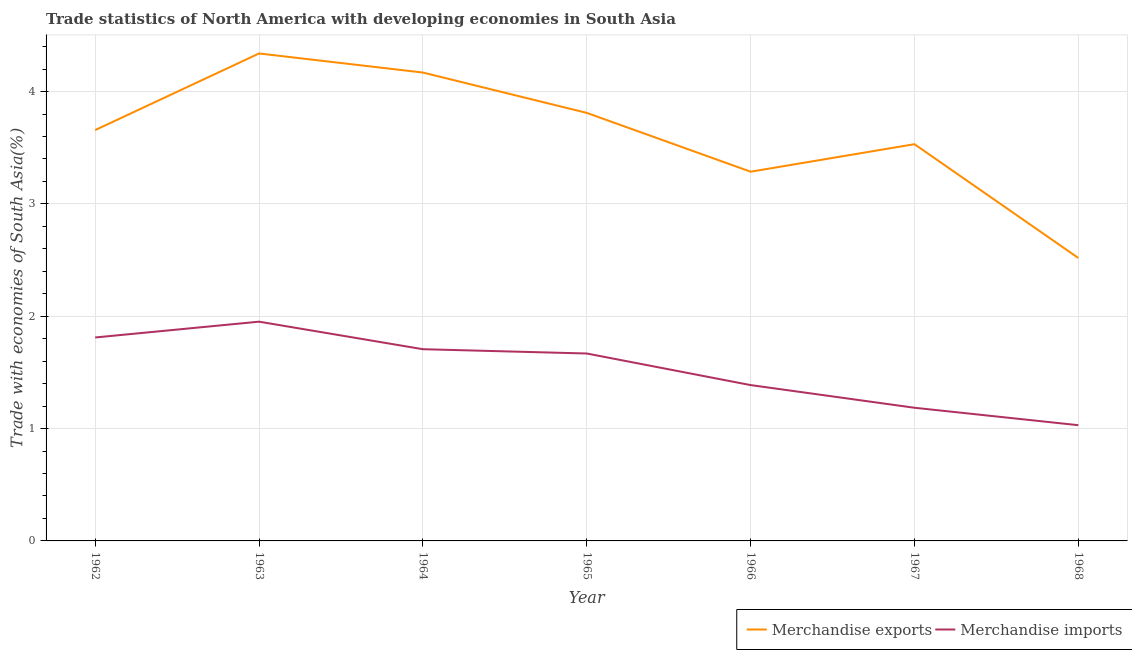Does the line corresponding to merchandise imports intersect with the line corresponding to merchandise exports?
Your answer should be very brief. No. What is the merchandise imports in 1965?
Your answer should be very brief. 1.67. Across all years, what is the maximum merchandise imports?
Keep it short and to the point. 1.95. Across all years, what is the minimum merchandise exports?
Offer a very short reply. 2.52. In which year was the merchandise exports minimum?
Your answer should be compact. 1968. What is the total merchandise imports in the graph?
Offer a very short reply. 10.74. What is the difference between the merchandise exports in 1964 and that in 1966?
Keep it short and to the point. 0.88. What is the difference between the merchandise imports in 1966 and the merchandise exports in 1962?
Offer a terse response. -2.27. What is the average merchandise imports per year?
Provide a short and direct response. 1.53. In the year 1968, what is the difference between the merchandise exports and merchandise imports?
Provide a succinct answer. 1.49. What is the ratio of the merchandise imports in 1966 to that in 1968?
Ensure brevity in your answer.  1.35. Is the difference between the merchandise exports in 1963 and 1966 greater than the difference between the merchandise imports in 1963 and 1966?
Offer a very short reply. Yes. What is the difference between the highest and the second highest merchandise exports?
Your answer should be compact. 0.17. What is the difference between the highest and the lowest merchandise imports?
Your response must be concise. 0.92. In how many years, is the merchandise exports greater than the average merchandise exports taken over all years?
Ensure brevity in your answer.  4. Is the sum of the merchandise imports in 1964 and 1965 greater than the maximum merchandise exports across all years?
Make the answer very short. No. How many years are there in the graph?
Provide a succinct answer. 7. Are the values on the major ticks of Y-axis written in scientific E-notation?
Provide a succinct answer. No. Does the graph contain any zero values?
Provide a short and direct response. No. Where does the legend appear in the graph?
Give a very brief answer. Bottom right. What is the title of the graph?
Your answer should be compact. Trade statistics of North America with developing economies in South Asia. Does "International Tourists" appear as one of the legend labels in the graph?
Your answer should be very brief. No. What is the label or title of the Y-axis?
Offer a terse response. Trade with economies of South Asia(%). What is the Trade with economies of South Asia(%) in Merchandise exports in 1962?
Give a very brief answer. 3.66. What is the Trade with economies of South Asia(%) of Merchandise imports in 1962?
Your answer should be compact. 1.81. What is the Trade with economies of South Asia(%) of Merchandise exports in 1963?
Offer a very short reply. 4.34. What is the Trade with economies of South Asia(%) in Merchandise imports in 1963?
Provide a short and direct response. 1.95. What is the Trade with economies of South Asia(%) in Merchandise exports in 1964?
Ensure brevity in your answer.  4.17. What is the Trade with economies of South Asia(%) in Merchandise imports in 1964?
Ensure brevity in your answer.  1.71. What is the Trade with economies of South Asia(%) in Merchandise exports in 1965?
Your answer should be very brief. 3.81. What is the Trade with economies of South Asia(%) of Merchandise imports in 1965?
Keep it short and to the point. 1.67. What is the Trade with economies of South Asia(%) of Merchandise exports in 1966?
Your answer should be very brief. 3.29. What is the Trade with economies of South Asia(%) in Merchandise imports in 1966?
Your answer should be very brief. 1.39. What is the Trade with economies of South Asia(%) of Merchandise exports in 1967?
Your answer should be very brief. 3.53. What is the Trade with economies of South Asia(%) in Merchandise imports in 1967?
Your response must be concise. 1.19. What is the Trade with economies of South Asia(%) in Merchandise exports in 1968?
Keep it short and to the point. 2.52. What is the Trade with economies of South Asia(%) of Merchandise imports in 1968?
Give a very brief answer. 1.03. Across all years, what is the maximum Trade with economies of South Asia(%) of Merchandise exports?
Ensure brevity in your answer.  4.34. Across all years, what is the maximum Trade with economies of South Asia(%) in Merchandise imports?
Your response must be concise. 1.95. Across all years, what is the minimum Trade with economies of South Asia(%) in Merchandise exports?
Offer a very short reply. 2.52. Across all years, what is the minimum Trade with economies of South Asia(%) in Merchandise imports?
Make the answer very short. 1.03. What is the total Trade with economies of South Asia(%) in Merchandise exports in the graph?
Keep it short and to the point. 25.31. What is the total Trade with economies of South Asia(%) of Merchandise imports in the graph?
Give a very brief answer. 10.74. What is the difference between the Trade with economies of South Asia(%) in Merchandise exports in 1962 and that in 1963?
Give a very brief answer. -0.68. What is the difference between the Trade with economies of South Asia(%) of Merchandise imports in 1962 and that in 1963?
Provide a succinct answer. -0.14. What is the difference between the Trade with economies of South Asia(%) in Merchandise exports in 1962 and that in 1964?
Give a very brief answer. -0.51. What is the difference between the Trade with economies of South Asia(%) in Merchandise imports in 1962 and that in 1964?
Keep it short and to the point. 0.1. What is the difference between the Trade with economies of South Asia(%) in Merchandise exports in 1962 and that in 1965?
Your answer should be compact. -0.15. What is the difference between the Trade with economies of South Asia(%) in Merchandise imports in 1962 and that in 1965?
Ensure brevity in your answer.  0.14. What is the difference between the Trade with economies of South Asia(%) of Merchandise exports in 1962 and that in 1966?
Make the answer very short. 0.37. What is the difference between the Trade with economies of South Asia(%) of Merchandise imports in 1962 and that in 1966?
Provide a short and direct response. 0.42. What is the difference between the Trade with economies of South Asia(%) in Merchandise exports in 1962 and that in 1967?
Your answer should be compact. 0.13. What is the difference between the Trade with economies of South Asia(%) in Merchandise imports in 1962 and that in 1967?
Provide a short and direct response. 0.63. What is the difference between the Trade with economies of South Asia(%) of Merchandise exports in 1962 and that in 1968?
Offer a terse response. 1.14. What is the difference between the Trade with economies of South Asia(%) in Merchandise imports in 1962 and that in 1968?
Offer a very short reply. 0.78. What is the difference between the Trade with economies of South Asia(%) in Merchandise exports in 1963 and that in 1964?
Your answer should be compact. 0.17. What is the difference between the Trade with economies of South Asia(%) of Merchandise imports in 1963 and that in 1964?
Your answer should be compact. 0.25. What is the difference between the Trade with economies of South Asia(%) of Merchandise exports in 1963 and that in 1965?
Your answer should be very brief. 0.53. What is the difference between the Trade with economies of South Asia(%) of Merchandise imports in 1963 and that in 1965?
Your response must be concise. 0.28. What is the difference between the Trade with economies of South Asia(%) of Merchandise exports in 1963 and that in 1966?
Your response must be concise. 1.05. What is the difference between the Trade with economies of South Asia(%) of Merchandise imports in 1963 and that in 1966?
Provide a succinct answer. 0.56. What is the difference between the Trade with economies of South Asia(%) of Merchandise exports in 1963 and that in 1967?
Offer a terse response. 0.81. What is the difference between the Trade with economies of South Asia(%) in Merchandise imports in 1963 and that in 1967?
Your answer should be compact. 0.77. What is the difference between the Trade with economies of South Asia(%) in Merchandise exports in 1963 and that in 1968?
Provide a succinct answer. 1.82. What is the difference between the Trade with economies of South Asia(%) in Merchandise imports in 1963 and that in 1968?
Your answer should be very brief. 0.92. What is the difference between the Trade with economies of South Asia(%) of Merchandise exports in 1964 and that in 1965?
Your answer should be compact. 0.36. What is the difference between the Trade with economies of South Asia(%) of Merchandise imports in 1964 and that in 1965?
Give a very brief answer. 0.04. What is the difference between the Trade with economies of South Asia(%) in Merchandise exports in 1964 and that in 1966?
Provide a succinct answer. 0.88. What is the difference between the Trade with economies of South Asia(%) in Merchandise imports in 1964 and that in 1966?
Keep it short and to the point. 0.32. What is the difference between the Trade with economies of South Asia(%) in Merchandise exports in 1964 and that in 1967?
Your response must be concise. 0.64. What is the difference between the Trade with economies of South Asia(%) in Merchandise imports in 1964 and that in 1967?
Keep it short and to the point. 0.52. What is the difference between the Trade with economies of South Asia(%) in Merchandise exports in 1964 and that in 1968?
Ensure brevity in your answer.  1.65. What is the difference between the Trade with economies of South Asia(%) in Merchandise imports in 1964 and that in 1968?
Make the answer very short. 0.68. What is the difference between the Trade with economies of South Asia(%) of Merchandise exports in 1965 and that in 1966?
Make the answer very short. 0.52. What is the difference between the Trade with economies of South Asia(%) in Merchandise imports in 1965 and that in 1966?
Your answer should be compact. 0.28. What is the difference between the Trade with economies of South Asia(%) of Merchandise exports in 1965 and that in 1967?
Give a very brief answer. 0.28. What is the difference between the Trade with economies of South Asia(%) in Merchandise imports in 1965 and that in 1967?
Offer a terse response. 0.48. What is the difference between the Trade with economies of South Asia(%) in Merchandise exports in 1965 and that in 1968?
Your response must be concise. 1.29. What is the difference between the Trade with economies of South Asia(%) in Merchandise imports in 1965 and that in 1968?
Ensure brevity in your answer.  0.64. What is the difference between the Trade with economies of South Asia(%) in Merchandise exports in 1966 and that in 1967?
Keep it short and to the point. -0.24. What is the difference between the Trade with economies of South Asia(%) of Merchandise imports in 1966 and that in 1967?
Provide a short and direct response. 0.2. What is the difference between the Trade with economies of South Asia(%) of Merchandise exports in 1966 and that in 1968?
Provide a short and direct response. 0.77. What is the difference between the Trade with economies of South Asia(%) in Merchandise imports in 1966 and that in 1968?
Offer a terse response. 0.36. What is the difference between the Trade with economies of South Asia(%) of Merchandise exports in 1967 and that in 1968?
Offer a terse response. 1.01. What is the difference between the Trade with economies of South Asia(%) in Merchandise imports in 1967 and that in 1968?
Ensure brevity in your answer.  0.16. What is the difference between the Trade with economies of South Asia(%) in Merchandise exports in 1962 and the Trade with economies of South Asia(%) in Merchandise imports in 1963?
Ensure brevity in your answer.  1.71. What is the difference between the Trade with economies of South Asia(%) of Merchandise exports in 1962 and the Trade with economies of South Asia(%) of Merchandise imports in 1964?
Offer a terse response. 1.95. What is the difference between the Trade with economies of South Asia(%) of Merchandise exports in 1962 and the Trade with economies of South Asia(%) of Merchandise imports in 1965?
Keep it short and to the point. 1.99. What is the difference between the Trade with economies of South Asia(%) of Merchandise exports in 1962 and the Trade with economies of South Asia(%) of Merchandise imports in 1966?
Give a very brief answer. 2.27. What is the difference between the Trade with economies of South Asia(%) in Merchandise exports in 1962 and the Trade with economies of South Asia(%) in Merchandise imports in 1967?
Your answer should be compact. 2.47. What is the difference between the Trade with economies of South Asia(%) of Merchandise exports in 1962 and the Trade with economies of South Asia(%) of Merchandise imports in 1968?
Provide a short and direct response. 2.63. What is the difference between the Trade with economies of South Asia(%) in Merchandise exports in 1963 and the Trade with economies of South Asia(%) in Merchandise imports in 1964?
Offer a very short reply. 2.63. What is the difference between the Trade with economies of South Asia(%) of Merchandise exports in 1963 and the Trade with economies of South Asia(%) of Merchandise imports in 1965?
Give a very brief answer. 2.67. What is the difference between the Trade with economies of South Asia(%) of Merchandise exports in 1963 and the Trade with economies of South Asia(%) of Merchandise imports in 1966?
Offer a very short reply. 2.95. What is the difference between the Trade with economies of South Asia(%) in Merchandise exports in 1963 and the Trade with economies of South Asia(%) in Merchandise imports in 1967?
Your answer should be very brief. 3.15. What is the difference between the Trade with economies of South Asia(%) in Merchandise exports in 1963 and the Trade with economies of South Asia(%) in Merchandise imports in 1968?
Your response must be concise. 3.31. What is the difference between the Trade with economies of South Asia(%) of Merchandise exports in 1964 and the Trade with economies of South Asia(%) of Merchandise imports in 1965?
Provide a succinct answer. 2.5. What is the difference between the Trade with economies of South Asia(%) in Merchandise exports in 1964 and the Trade with economies of South Asia(%) in Merchandise imports in 1966?
Provide a short and direct response. 2.78. What is the difference between the Trade with economies of South Asia(%) in Merchandise exports in 1964 and the Trade with economies of South Asia(%) in Merchandise imports in 1967?
Make the answer very short. 2.98. What is the difference between the Trade with economies of South Asia(%) of Merchandise exports in 1964 and the Trade with economies of South Asia(%) of Merchandise imports in 1968?
Ensure brevity in your answer.  3.14. What is the difference between the Trade with economies of South Asia(%) of Merchandise exports in 1965 and the Trade with economies of South Asia(%) of Merchandise imports in 1966?
Your response must be concise. 2.42. What is the difference between the Trade with economies of South Asia(%) in Merchandise exports in 1965 and the Trade with economies of South Asia(%) in Merchandise imports in 1967?
Offer a very short reply. 2.62. What is the difference between the Trade with economies of South Asia(%) in Merchandise exports in 1965 and the Trade with economies of South Asia(%) in Merchandise imports in 1968?
Provide a succinct answer. 2.78. What is the difference between the Trade with economies of South Asia(%) of Merchandise exports in 1966 and the Trade with economies of South Asia(%) of Merchandise imports in 1967?
Ensure brevity in your answer.  2.1. What is the difference between the Trade with economies of South Asia(%) in Merchandise exports in 1966 and the Trade with economies of South Asia(%) in Merchandise imports in 1968?
Offer a terse response. 2.26. What is the difference between the Trade with economies of South Asia(%) in Merchandise exports in 1967 and the Trade with economies of South Asia(%) in Merchandise imports in 1968?
Provide a succinct answer. 2.5. What is the average Trade with economies of South Asia(%) in Merchandise exports per year?
Ensure brevity in your answer.  3.62. What is the average Trade with economies of South Asia(%) of Merchandise imports per year?
Keep it short and to the point. 1.53. In the year 1962, what is the difference between the Trade with economies of South Asia(%) of Merchandise exports and Trade with economies of South Asia(%) of Merchandise imports?
Your response must be concise. 1.85. In the year 1963, what is the difference between the Trade with economies of South Asia(%) in Merchandise exports and Trade with economies of South Asia(%) in Merchandise imports?
Offer a very short reply. 2.39. In the year 1964, what is the difference between the Trade with economies of South Asia(%) of Merchandise exports and Trade with economies of South Asia(%) of Merchandise imports?
Ensure brevity in your answer.  2.46. In the year 1965, what is the difference between the Trade with economies of South Asia(%) of Merchandise exports and Trade with economies of South Asia(%) of Merchandise imports?
Keep it short and to the point. 2.14. In the year 1966, what is the difference between the Trade with economies of South Asia(%) of Merchandise exports and Trade with economies of South Asia(%) of Merchandise imports?
Give a very brief answer. 1.9. In the year 1967, what is the difference between the Trade with economies of South Asia(%) of Merchandise exports and Trade with economies of South Asia(%) of Merchandise imports?
Provide a succinct answer. 2.35. In the year 1968, what is the difference between the Trade with economies of South Asia(%) of Merchandise exports and Trade with economies of South Asia(%) of Merchandise imports?
Make the answer very short. 1.49. What is the ratio of the Trade with economies of South Asia(%) of Merchandise exports in 1962 to that in 1963?
Keep it short and to the point. 0.84. What is the ratio of the Trade with economies of South Asia(%) in Merchandise imports in 1962 to that in 1963?
Offer a very short reply. 0.93. What is the ratio of the Trade with economies of South Asia(%) of Merchandise exports in 1962 to that in 1964?
Make the answer very short. 0.88. What is the ratio of the Trade with economies of South Asia(%) of Merchandise imports in 1962 to that in 1964?
Your response must be concise. 1.06. What is the ratio of the Trade with economies of South Asia(%) of Merchandise exports in 1962 to that in 1965?
Provide a succinct answer. 0.96. What is the ratio of the Trade with economies of South Asia(%) of Merchandise imports in 1962 to that in 1965?
Offer a terse response. 1.09. What is the ratio of the Trade with economies of South Asia(%) of Merchandise exports in 1962 to that in 1966?
Your response must be concise. 1.11. What is the ratio of the Trade with economies of South Asia(%) in Merchandise imports in 1962 to that in 1966?
Offer a terse response. 1.31. What is the ratio of the Trade with economies of South Asia(%) in Merchandise exports in 1962 to that in 1967?
Ensure brevity in your answer.  1.04. What is the ratio of the Trade with economies of South Asia(%) of Merchandise imports in 1962 to that in 1967?
Provide a short and direct response. 1.53. What is the ratio of the Trade with economies of South Asia(%) of Merchandise exports in 1962 to that in 1968?
Ensure brevity in your answer.  1.45. What is the ratio of the Trade with economies of South Asia(%) of Merchandise imports in 1962 to that in 1968?
Ensure brevity in your answer.  1.76. What is the ratio of the Trade with economies of South Asia(%) of Merchandise exports in 1963 to that in 1964?
Offer a very short reply. 1.04. What is the ratio of the Trade with economies of South Asia(%) in Merchandise imports in 1963 to that in 1964?
Ensure brevity in your answer.  1.14. What is the ratio of the Trade with economies of South Asia(%) of Merchandise exports in 1963 to that in 1965?
Your answer should be compact. 1.14. What is the ratio of the Trade with economies of South Asia(%) in Merchandise imports in 1963 to that in 1965?
Provide a short and direct response. 1.17. What is the ratio of the Trade with economies of South Asia(%) of Merchandise exports in 1963 to that in 1966?
Provide a succinct answer. 1.32. What is the ratio of the Trade with economies of South Asia(%) in Merchandise imports in 1963 to that in 1966?
Offer a very short reply. 1.41. What is the ratio of the Trade with economies of South Asia(%) of Merchandise exports in 1963 to that in 1967?
Give a very brief answer. 1.23. What is the ratio of the Trade with economies of South Asia(%) of Merchandise imports in 1963 to that in 1967?
Keep it short and to the point. 1.65. What is the ratio of the Trade with economies of South Asia(%) of Merchandise exports in 1963 to that in 1968?
Offer a terse response. 1.72. What is the ratio of the Trade with economies of South Asia(%) of Merchandise imports in 1963 to that in 1968?
Provide a succinct answer. 1.89. What is the ratio of the Trade with economies of South Asia(%) of Merchandise exports in 1964 to that in 1965?
Your response must be concise. 1.09. What is the ratio of the Trade with economies of South Asia(%) in Merchandise imports in 1964 to that in 1965?
Offer a very short reply. 1.02. What is the ratio of the Trade with economies of South Asia(%) in Merchandise exports in 1964 to that in 1966?
Keep it short and to the point. 1.27. What is the ratio of the Trade with economies of South Asia(%) of Merchandise imports in 1964 to that in 1966?
Ensure brevity in your answer.  1.23. What is the ratio of the Trade with economies of South Asia(%) of Merchandise exports in 1964 to that in 1967?
Keep it short and to the point. 1.18. What is the ratio of the Trade with economies of South Asia(%) of Merchandise imports in 1964 to that in 1967?
Keep it short and to the point. 1.44. What is the ratio of the Trade with economies of South Asia(%) in Merchandise exports in 1964 to that in 1968?
Keep it short and to the point. 1.66. What is the ratio of the Trade with economies of South Asia(%) in Merchandise imports in 1964 to that in 1968?
Offer a very short reply. 1.66. What is the ratio of the Trade with economies of South Asia(%) in Merchandise exports in 1965 to that in 1966?
Offer a terse response. 1.16. What is the ratio of the Trade with economies of South Asia(%) of Merchandise imports in 1965 to that in 1966?
Provide a short and direct response. 1.2. What is the ratio of the Trade with economies of South Asia(%) of Merchandise exports in 1965 to that in 1967?
Provide a succinct answer. 1.08. What is the ratio of the Trade with economies of South Asia(%) in Merchandise imports in 1965 to that in 1967?
Keep it short and to the point. 1.41. What is the ratio of the Trade with economies of South Asia(%) in Merchandise exports in 1965 to that in 1968?
Offer a very short reply. 1.51. What is the ratio of the Trade with economies of South Asia(%) in Merchandise imports in 1965 to that in 1968?
Provide a short and direct response. 1.62. What is the ratio of the Trade with economies of South Asia(%) of Merchandise exports in 1966 to that in 1967?
Your answer should be very brief. 0.93. What is the ratio of the Trade with economies of South Asia(%) of Merchandise imports in 1966 to that in 1967?
Provide a succinct answer. 1.17. What is the ratio of the Trade with economies of South Asia(%) of Merchandise exports in 1966 to that in 1968?
Your response must be concise. 1.3. What is the ratio of the Trade with economies of South Asia(%) of Merchandise imports in 1966 to that in 1968?
Make the answer very short. 1.35. What is the ratio of the Trade with economies of South Asia(%) of Merchandise exports in 1967 to that in 1968?
Make the answer very short. 1.4. What is the ratio of the Trade with economies of South Asia(%) of Merchandise imports in 1967 to that in 1968?
Give a very brief answer. 1.15. What is the difference between the highest and the second highest Trade with economies of South Asia(%) in Merchandise exports?
Provide a succinct answer. 0.17. What is the difference between the highest and the second highest Trade with economies of South Asia(%) in Merchandise imports?
Ensure brevity in your answer.  0.14. What is the difference between the highest and the lowest Trade with economies of South Asia(%) in Merchandise exports?
Make the answer very short. 1.82. What is the difference between the highest and the lowest Trade with economies of South Asia(%) in Merchandise imports?
Ensure brevity in your answer.  0.92. 